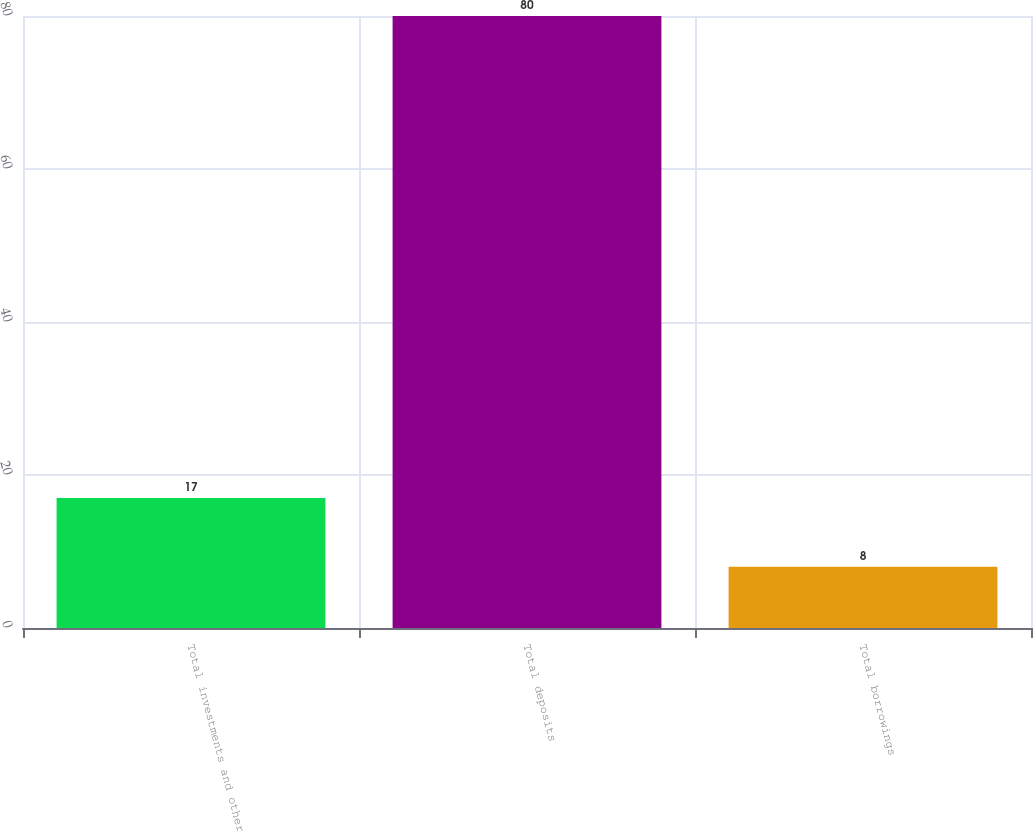Convert chart. <chart><loc_0><loc_0><loc_500><loc_500><bar_chart><fcel>Total investments and other<fcel>Total deposits<fcel>Total borrowings<nl><fcel>17<fcel>80<fcel>8<nl></chart> 